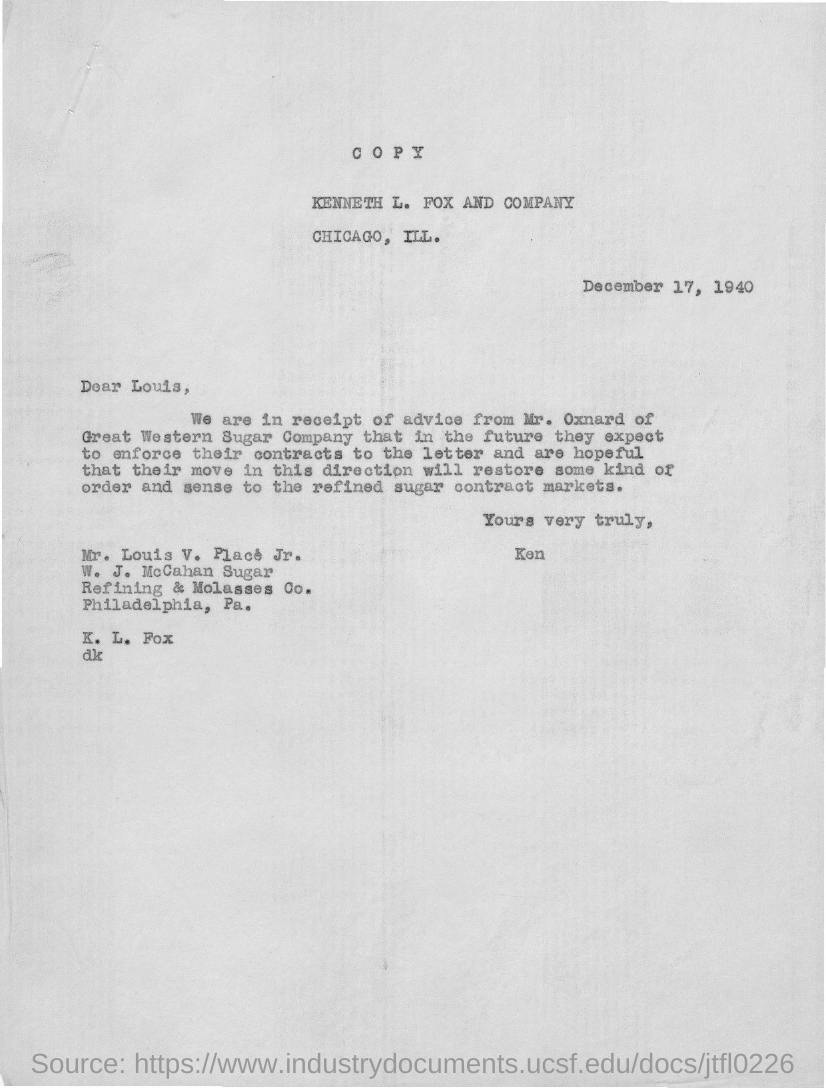What is the date on the document?
Keep it short and to the point. December 17, 1940. To Whom is this letter addressed to?
Offer a terse response. Louis, Louis V. Place Jr. Who is this letter from?
Your answer should be compact. Ken. Whose advice are they in receipt of?
Give a very brief answer. Mr. Oxnard. 